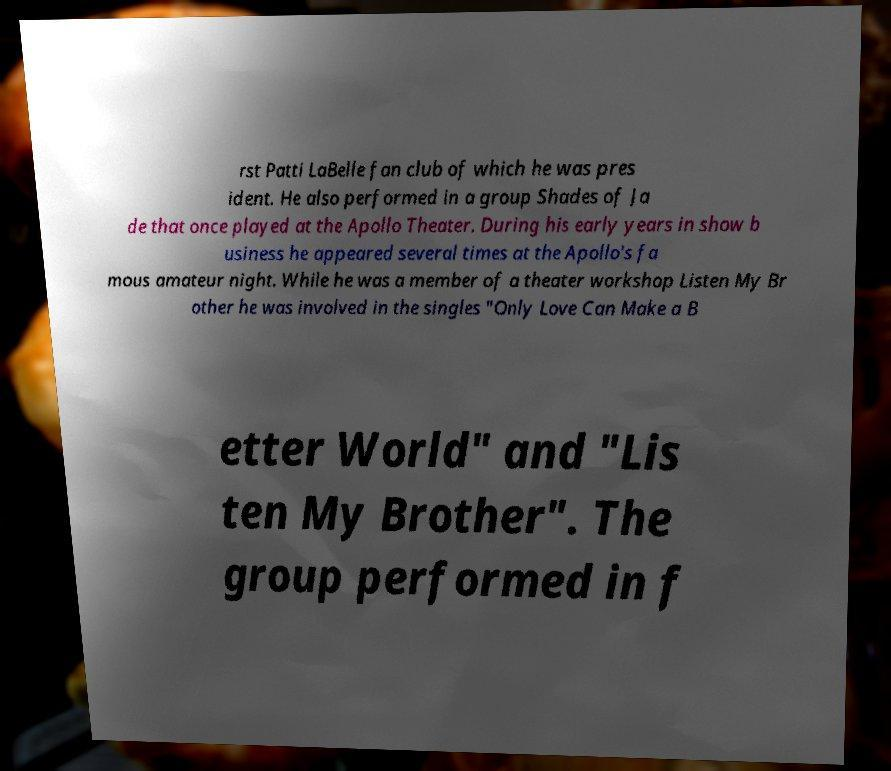For documentation purposes, I need the text within this image transcribed. Could you provide that? rst Patti LaBelle fan club of which he was pres ident. He also performed in a group Shades of Ja de that once played at the Apollo Theater. During his early years in show b usiness he appeared several times at the Apollo's fa mous amateur night. While he was a member of a theater workshop Listen My Br other he was involved in the singles "Only Love Can Make a B etter World" and "Lis ten My Brother". The group performed in f 